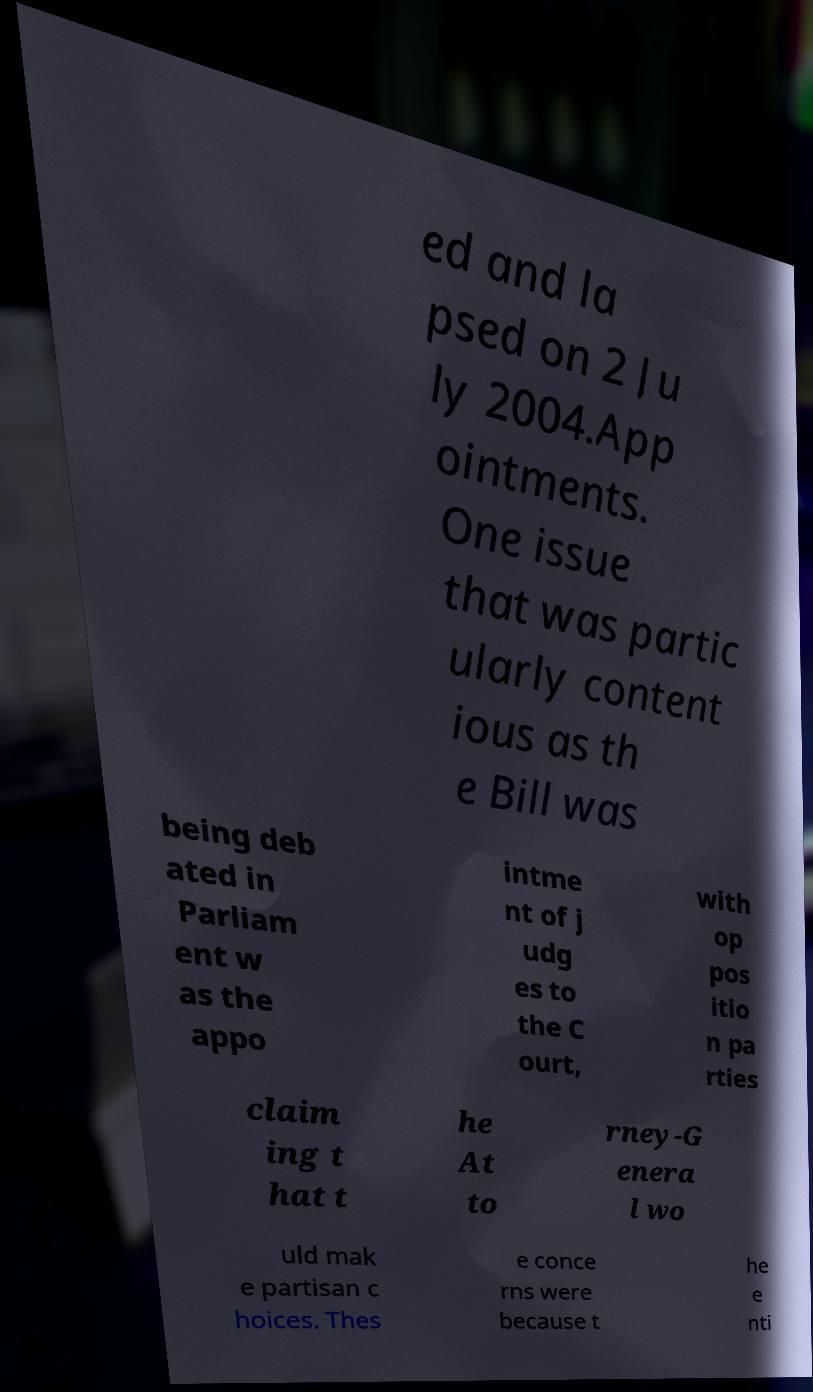Please read and relay the text visible in this image. What does it say? ed and la psed on 2 Ju ly 2004.App ointments. One issue that was partic ularly content ious as th e Bill was being deb ated in Parliam ent w as the appo intme nt of j udg es to the C ourt, with op pos itio n pa rties claim ing t hat t he At to rney-G enera l wo uld mak e partisan c hoices. Thes e conce rns were because t he e nti 